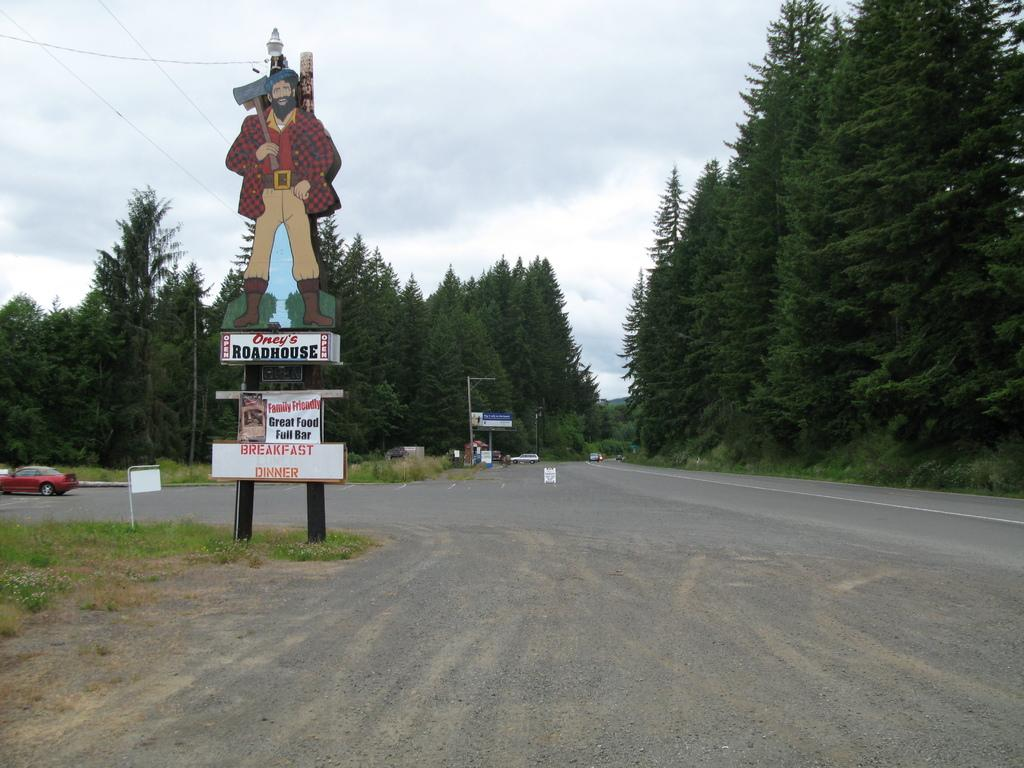What type of natural elements can be seen in the image? There are trees in the image. What man-made objects are present in the image? There are vehicles and boards with text in the image. Can you describe the board that resembles a person? Yes, there is a board that resembles a person in the image. What is visible in the sky in the image? The sky is visible in the image. What type of food is being served at the religious event in the image? There is no religious event or food present in the image. Can you tell me the name of the parent who is supervising the children in the image? There are no children or parents present in the image. 